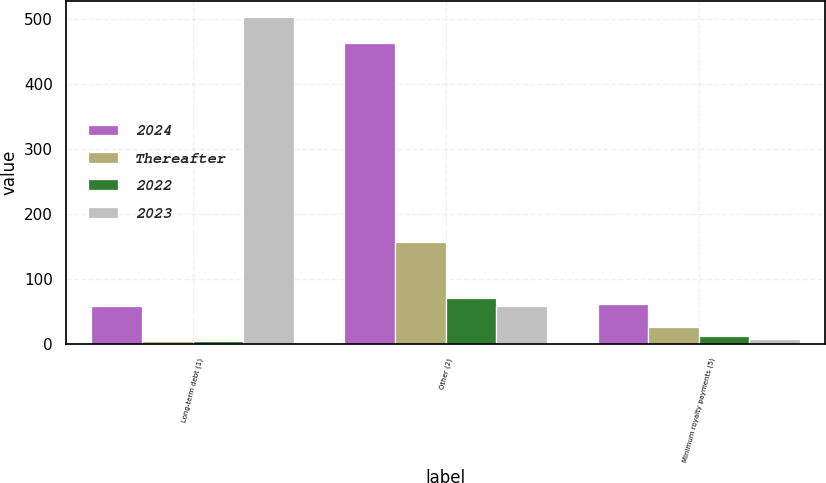<chart> <loc_0><loc_0><loc_500><loc_500><stacked_bar_chart><ecel><fcel>Long-term debt (1)<fcel>Other (2)<fcel>Minimum royalty payments (5)<nl><fcel>2024<fcel>58<fcel>463<fcel>61<nl><fcel>Thereafter<fcel>5<fcel>157<fcel>26<nl><fcel>2022<fcel>5<fcel>71<fcel>13<nl><fcel>2023<fcel>502<fcel>58<fcel>8<nl></chart> 